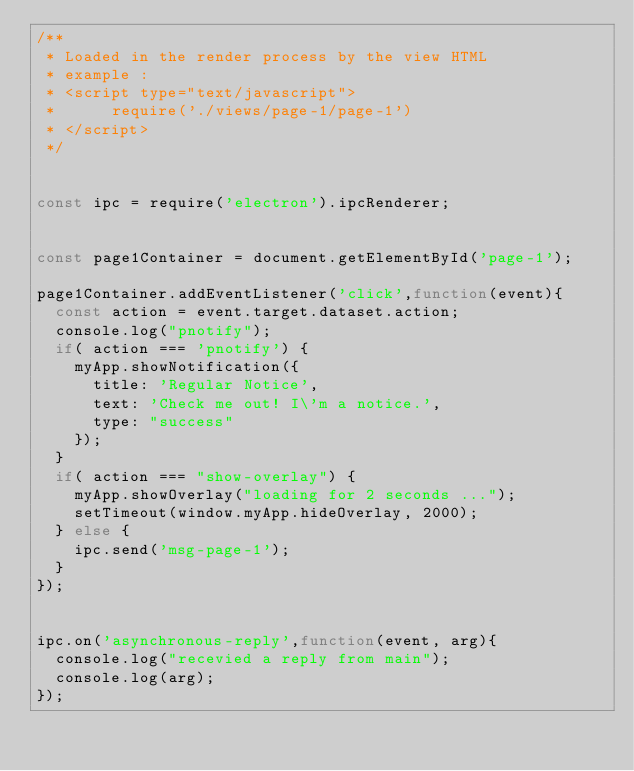Convert code to text. <code><loc_0><loc_0><loc_500><loc_500><_JavaScript_>/**
 * Loaded in the render process by the view HTML
 * example :
 * <script type="text/javascript">
 *      require('./views/page-1/page-1')
 * </script>
 */


const ipc = require('electron').ipcRenderer;


const page1Container = document.getElementById('page-1');

page1Container.addEventListener('click',function(event){
  const action = event.target.dataset.action;
  console.log("pnotify");
  if( action === 'pnotify') {
    myApp.showNotification({
      title: 'Regular Notice',
      text: 'Check me out! I\'m a notice.',
      type: "success"
    });
  }
  if( action === "show-overlay") {
    myApp.showOverlay("loading for 2 seconds ...");
    setTimeout(window.myApp.hideOverlay, 2000);
  } else {
    ipc.send('msg-page-1');
  }
});


ipc.on('asynchronous-reply',function(event, arg){
  console.log("recevied a reply from main");
  console.log(arg);
});
</code> 